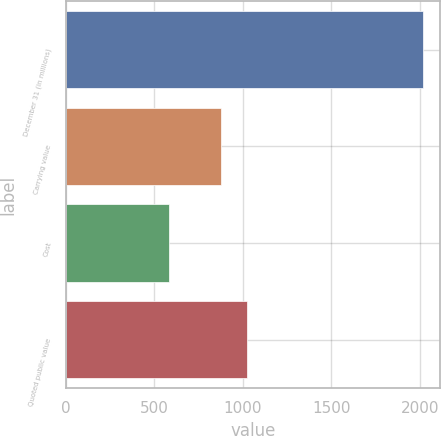Convert chart. <chart><loc_0><loc_0><loc_500><loc_500><bar_chart><fcel>December 31 (in millions)<fcel>Carrying value<fcel>Cost<fcel>Quoted public value<nl><fcel>2014<fcel>878<fcel>583<fcel>1021.1<nl></chart> 